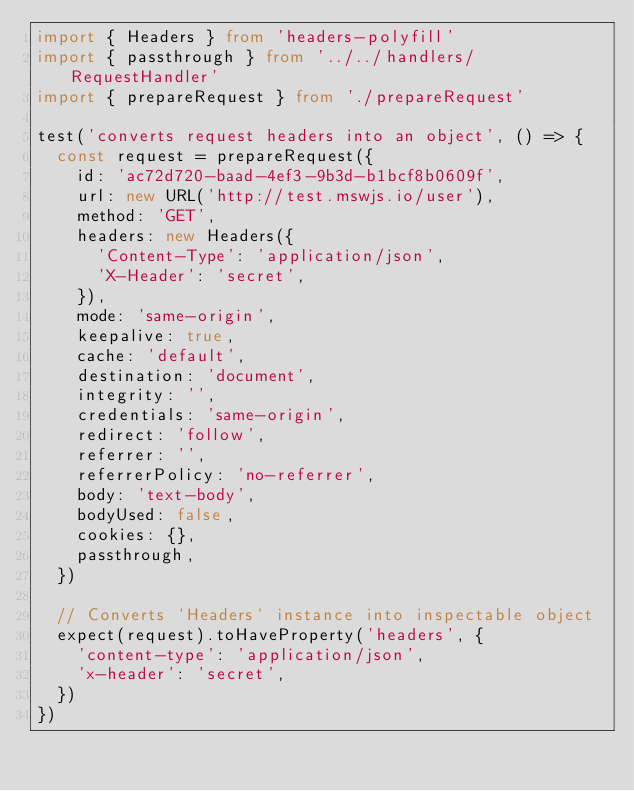<code> <loc_0><loc_0><loc_500><loc_500><_TypeScript_>import { Headers } from 'headers-polyfill'
import { passthrough } from '../../handlers/RequestHandler'
import { prepareRequest } from './prepareRequest'

test('converts request headers into an object', () => {
  const request = prepareRequest({
    id: 'ac72d720-baad-4ef3-9b3d-b1bcf8b0609f',
    url: new URL('http://test.mswjs.io/user'),
    method: 'GET',
    headers: new Headers({
      'Content-Type': 'application/json',
      'X-Header': 'secret',
    }),
    mode: 'same-origin',
    keepalive: true,
    cache: 'default',
    destination: 'document',
    integrity: '',
    credentials: 'same-origin',
    redirect: 'follow',
    referrer: '',
    referrerPolicy: 'no-referrer',
    body: 'text-body',
    bodyUsed: false,
    cookies: {},
    passthrough,
  })

  // Converts `Headers` instance into inspectable object
  expect(request).toHaveProperty('headers', {
    'content-type': 'application/json',
    'x-header': 'secret',
  })
})
</code> 